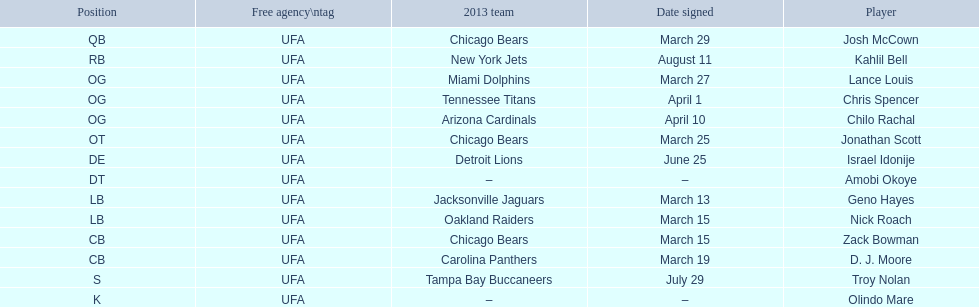Who are all of the players? Josh McCown, Kahlil Bell, Lance Louis, Chris Spencer, Chilo Rachal, Jonathan Scott, Israel Idonije, Amobi Okoye, Geno Hayes, Nick Roach, Zack Bowman, D. J. Moore, Troy Nolan, Olindo Mare. When were they signed? March 29, August 11, March 27, April 1, April 10, March 25, June 25, –, March 13, March 15, March 15, March 19, July 29, –. Along with nick roach, who else was signed on march 15? Zack Bowman. 